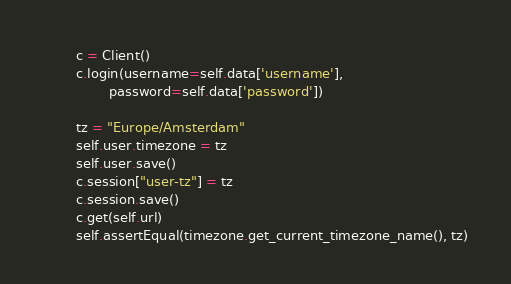<code> <loc_0><loc_0><loc_500><loc_500><_Python_>        c = Client()
        c.login(username=self.data['username'],
                password=self.data['password'])

        tz = "Europe/Amsterdam"
        self.user.timezone = tz
        self.user.save()
        c.session["user-tz"] = tz
        c.session.save()
        c.get(self.url)
        self.assertEqual(timezone.get_current_timezone_name(), tz)
</code> 